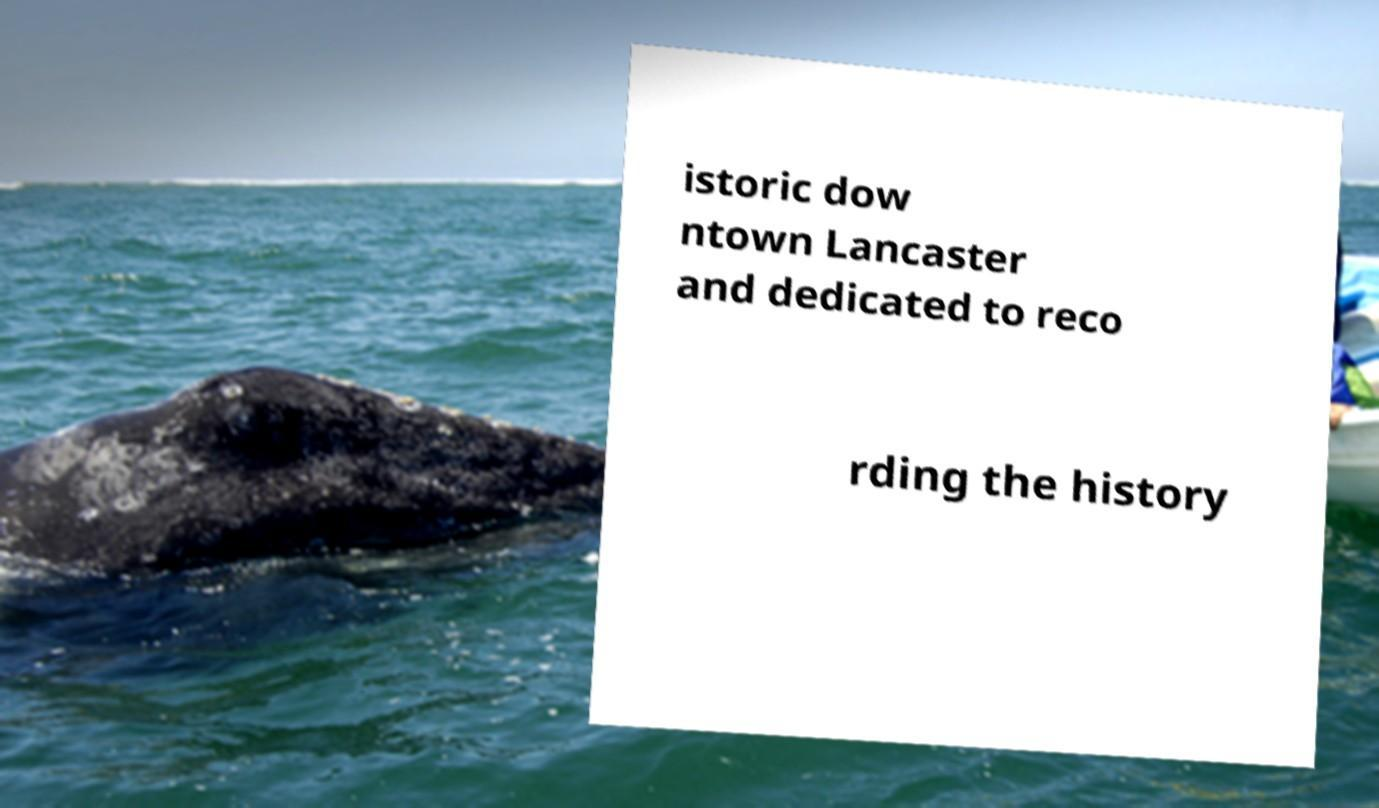Can you accurately transcribe the text from the provided image for me? istoric dow ntown Lancaster and dedicated to reco rding the history 